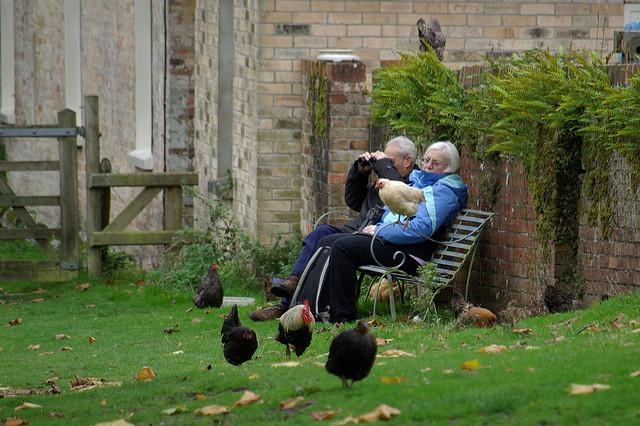What is the freshest food available to this woman? chicken 